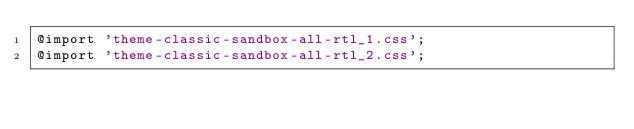Convert code to text. <code><loc_0><loc_0><loc_500><loc_500><_CSS_>@import 'theme-classic-sandbox-all-rtl_1.css';
@import 'theme-classic-sandbox-all-rtl_2.css';
</code> 